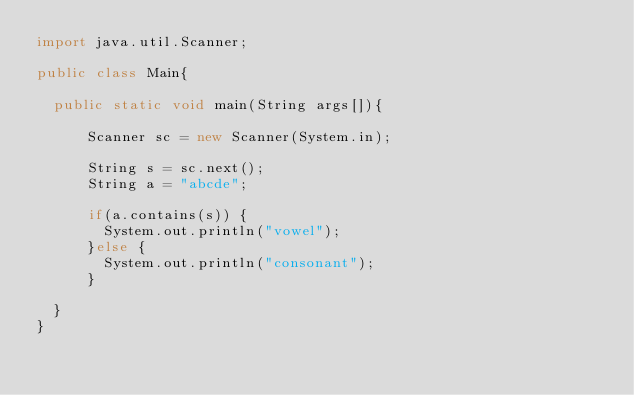Convert code to text. <code><loc_0><loc_0><loc_500><loc_500><_Java_>import java.util.Scanner;

public class Main{
		
	public static void main(String args[]){
		  
	    Scanner sc = new Scanner(System.in);
	    
	    String s = sc.next();
	    String a = "abcde";
	    
	    if(a.contains(s)) {
	    	System.out.println("vowel");
	    }else {
	    	System.out.println("consonant");
	    }
	    
	}
}</code> 